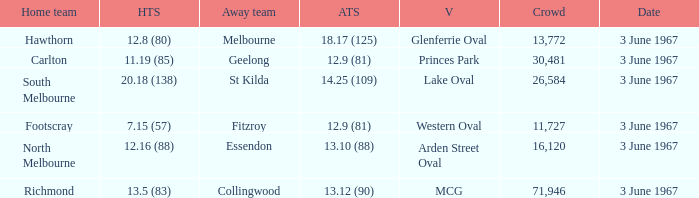Parse the table in full. {'header': ['Home team', 'HTS', 'Away team', 'ATS', 'V', 'Crowd', 'Date'], 'rows': [['Hawthorn', '12.8 (80)', 'Melbourne', '18.17 (125)', 'Glenferrie Oval', '13,772', '3 June 1967'], ['Carlton', '11.19 (85)', 'Geelong', '12.9 (81)', 'Princes Park', '30,481', '3 June 1967'], ['South Melbourne', '20.18 (138)', 'St Kilda', '14.25 (109)', 'Lake Oval', '26,584', '3 June 1967'], ['Footscray', '7.15 (57)', 'Fitzroy', '12.9 (81)', 'Western Oval', '11,727', '3 June 1967'], ['North Melbourne', '12.16 (88)', 'Essendon', '13.10 (88)', 'Arden Street Oval', '16,120', '3 June 1967'], ['Richmond', '13.5 (83)', 'Collingwood', '13.12 (90)', 'MCG', '71,946', '3 June 1967']]} Who was South Melbourne's away opponents? St Kilda. 